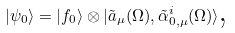Convert formula to latex. <formula><loc_0><loc_0><loc_500><loc_500>| \psi _ { 0 } \rangle = | f _ { 0 } \rangle \otimes | \tilde { a } _ { \mu } ( \Omega ) , \tilde { \alpha } ^ { i } _ { 0 , \mu } ( \Omega ) \rangle \text {,}</formula> 